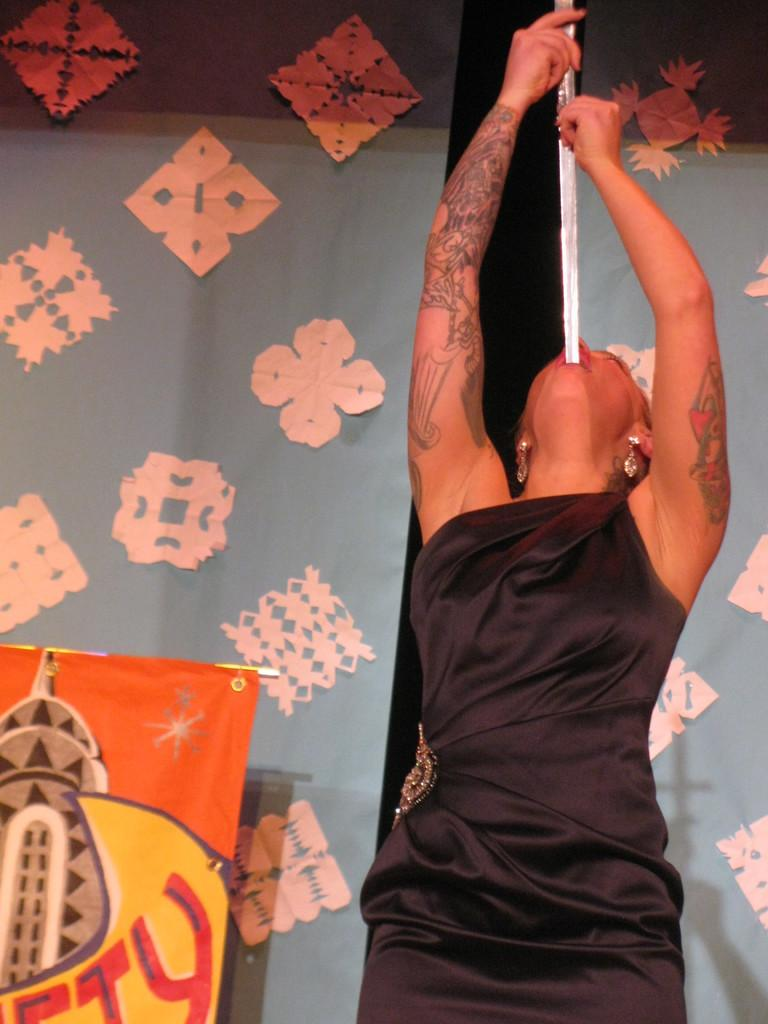What is the lady in the image wearing? There is a lady in a black dress in the image. What is the lady doing in the image? The lady is inserting a sword in her mouth. What can be seen in the background of the image? There is a wall with paper decorations in the background. What else is present in the image? There is a banner in the image. What type of soda is being served in the image? There is no soda present in the image. What need does the lady have that is being addressed in the image? The image does not depict a need being addressed; it shows the lady inserting a sword in her mouth. 